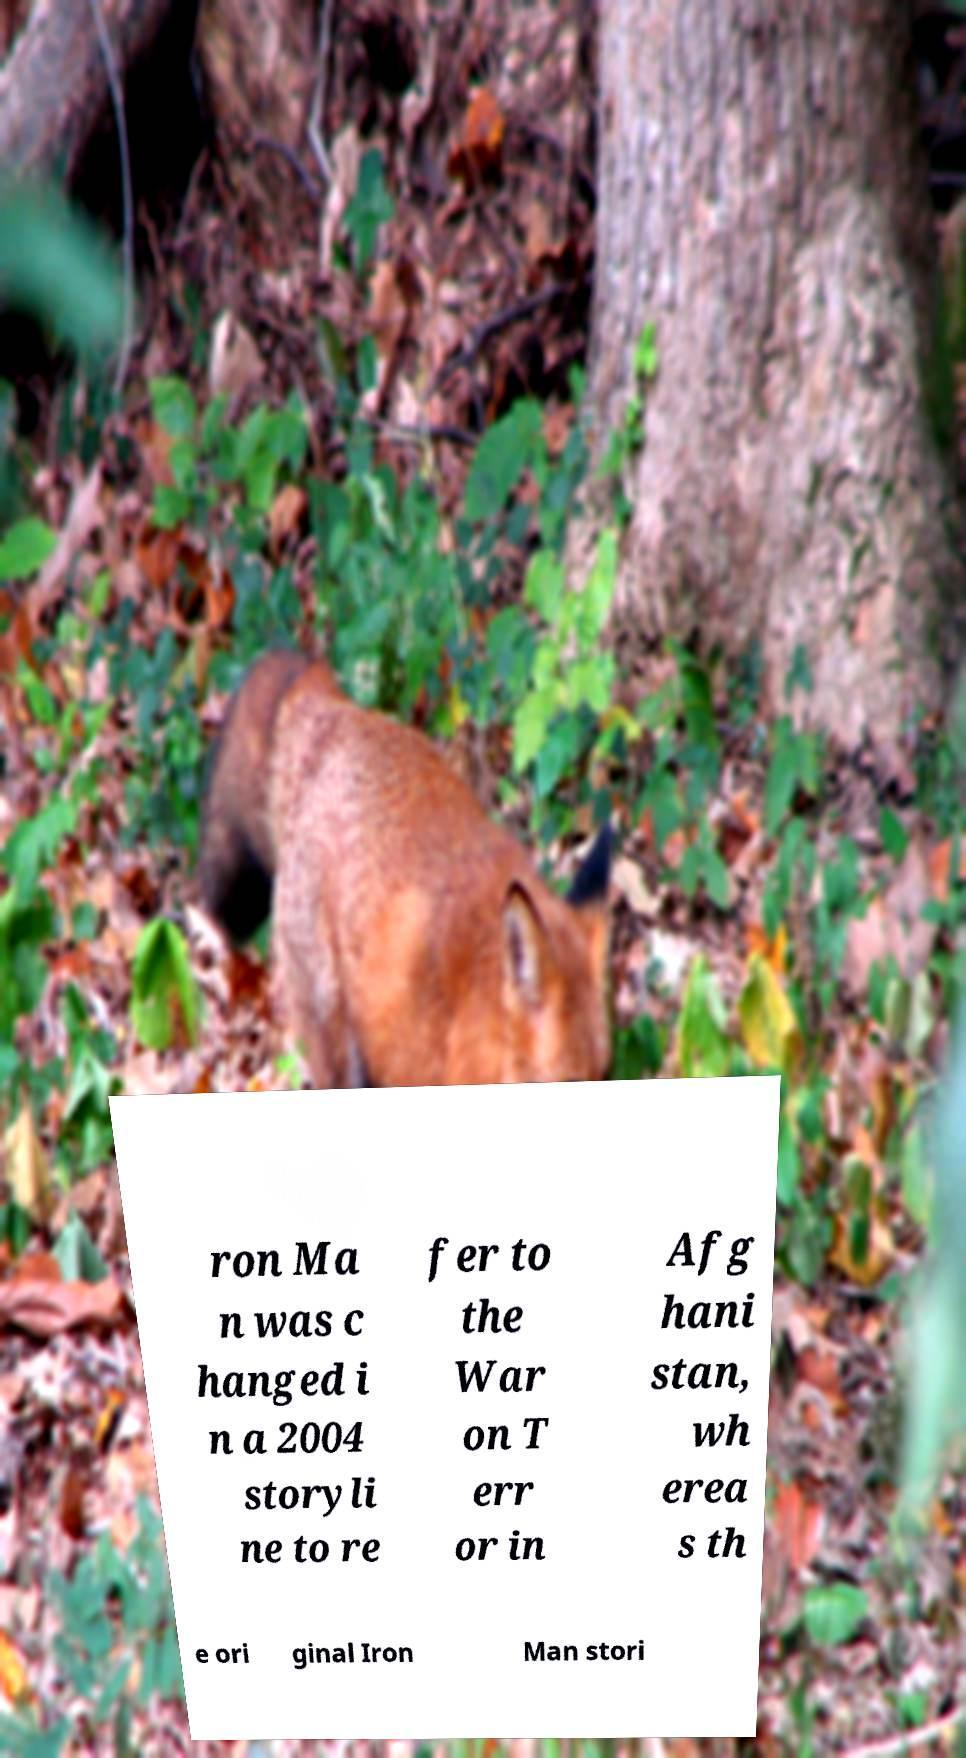For documentation purposes, I need the text within this image transcribed. Could you provide that? ron Ma n was c hanged i n a 2004 storyli ne to re fer to the War on T err or in Afg hani stan, wh erea s th e ori ginal Iron Man stori 